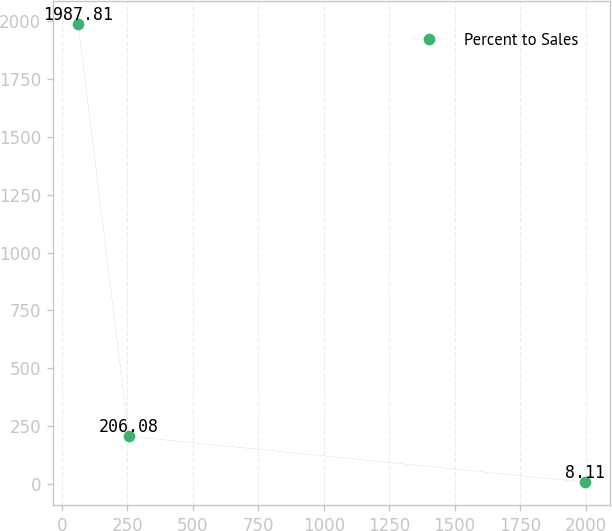Convert chart. <chart><loc_0><loc_0><loc_500><loc_500><line_chart><ecel><fcel>Percent to Sales<nl><fcel>62.31<fcel>1987.81<nl><fcel>255.88<fcel>206.08<nl><fcel>1998.03<fcel>8.11<nl></chart> 